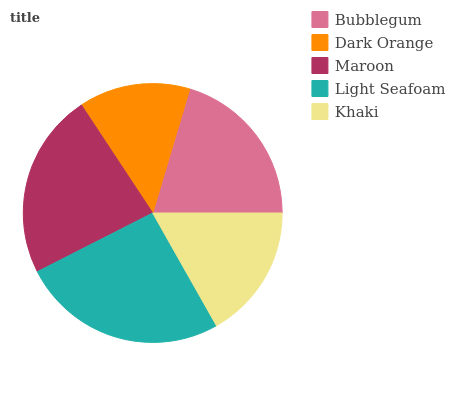Is Dark Orange the minimum?
Answer yes or no. Yes. Is Light Seafoam the maximum?
Answer yes or no. Yes. Is Maroon the minimum?
Answer yes or no. No. Is Maroon the maximum?
Answer yes or no. No. Is Maroon greater than Dark Orange?
Answer yes or no. Yes. Is Dark Orange less than Maroon?
Answer yes or no. Yes. Is Dark Orange greater than Maroon?
Answer yes or no. No. Is Maroon less than Dark Orange?
Answer yes or no. No. Is Bubblegum the high median?
Answer yes or no. Yes. Is Bubblegum the low median?
Answer yes or no. Yes. Is Dark Orange the high median?
Answer yes or no. No. Is Light Seafoam the low median?
Answer yes or no. No. 